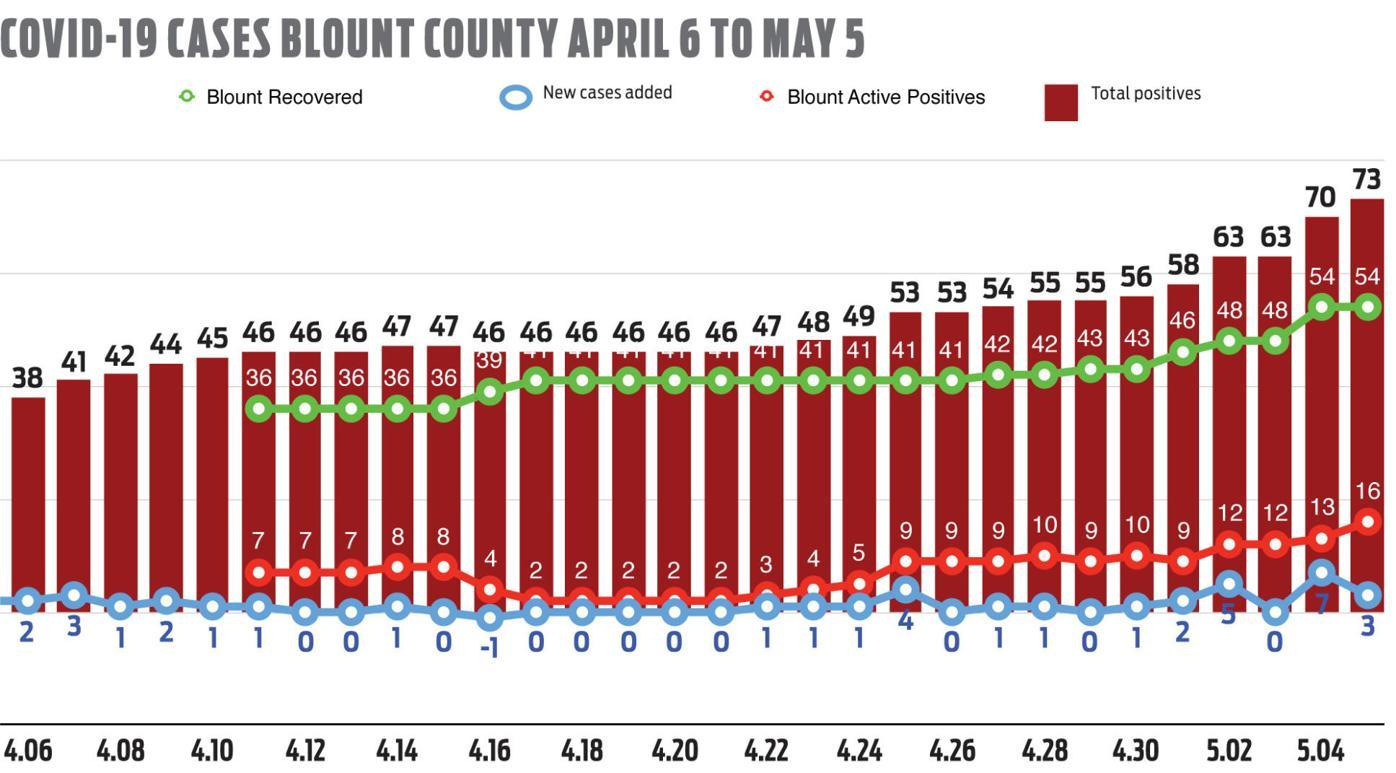Identify some key points in this picture. The Blount recovered rate was calculated when there was a total positive case of 55 for the second time, with a recovery rate of 43%. The recovered Blount rate that has occurred most frequently is 41. What is the highest positive count that occurred on all days? 46 was the total positive count. The highest value of new cases is 4. What is the second highest value of Blount recovery rate? The Blount recovery rate for a given year was 48%. 